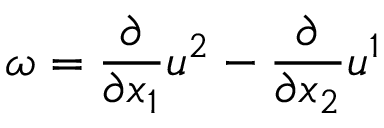<formula> <loc_0><loc_0><loc_500><loc_500>\omega = \frac { \partial } { \partial x _ { 1 } } u ^ { 2 } - \frac { \partial } { \partial x _ { 2 } } u ^ { 1 }</formula> 